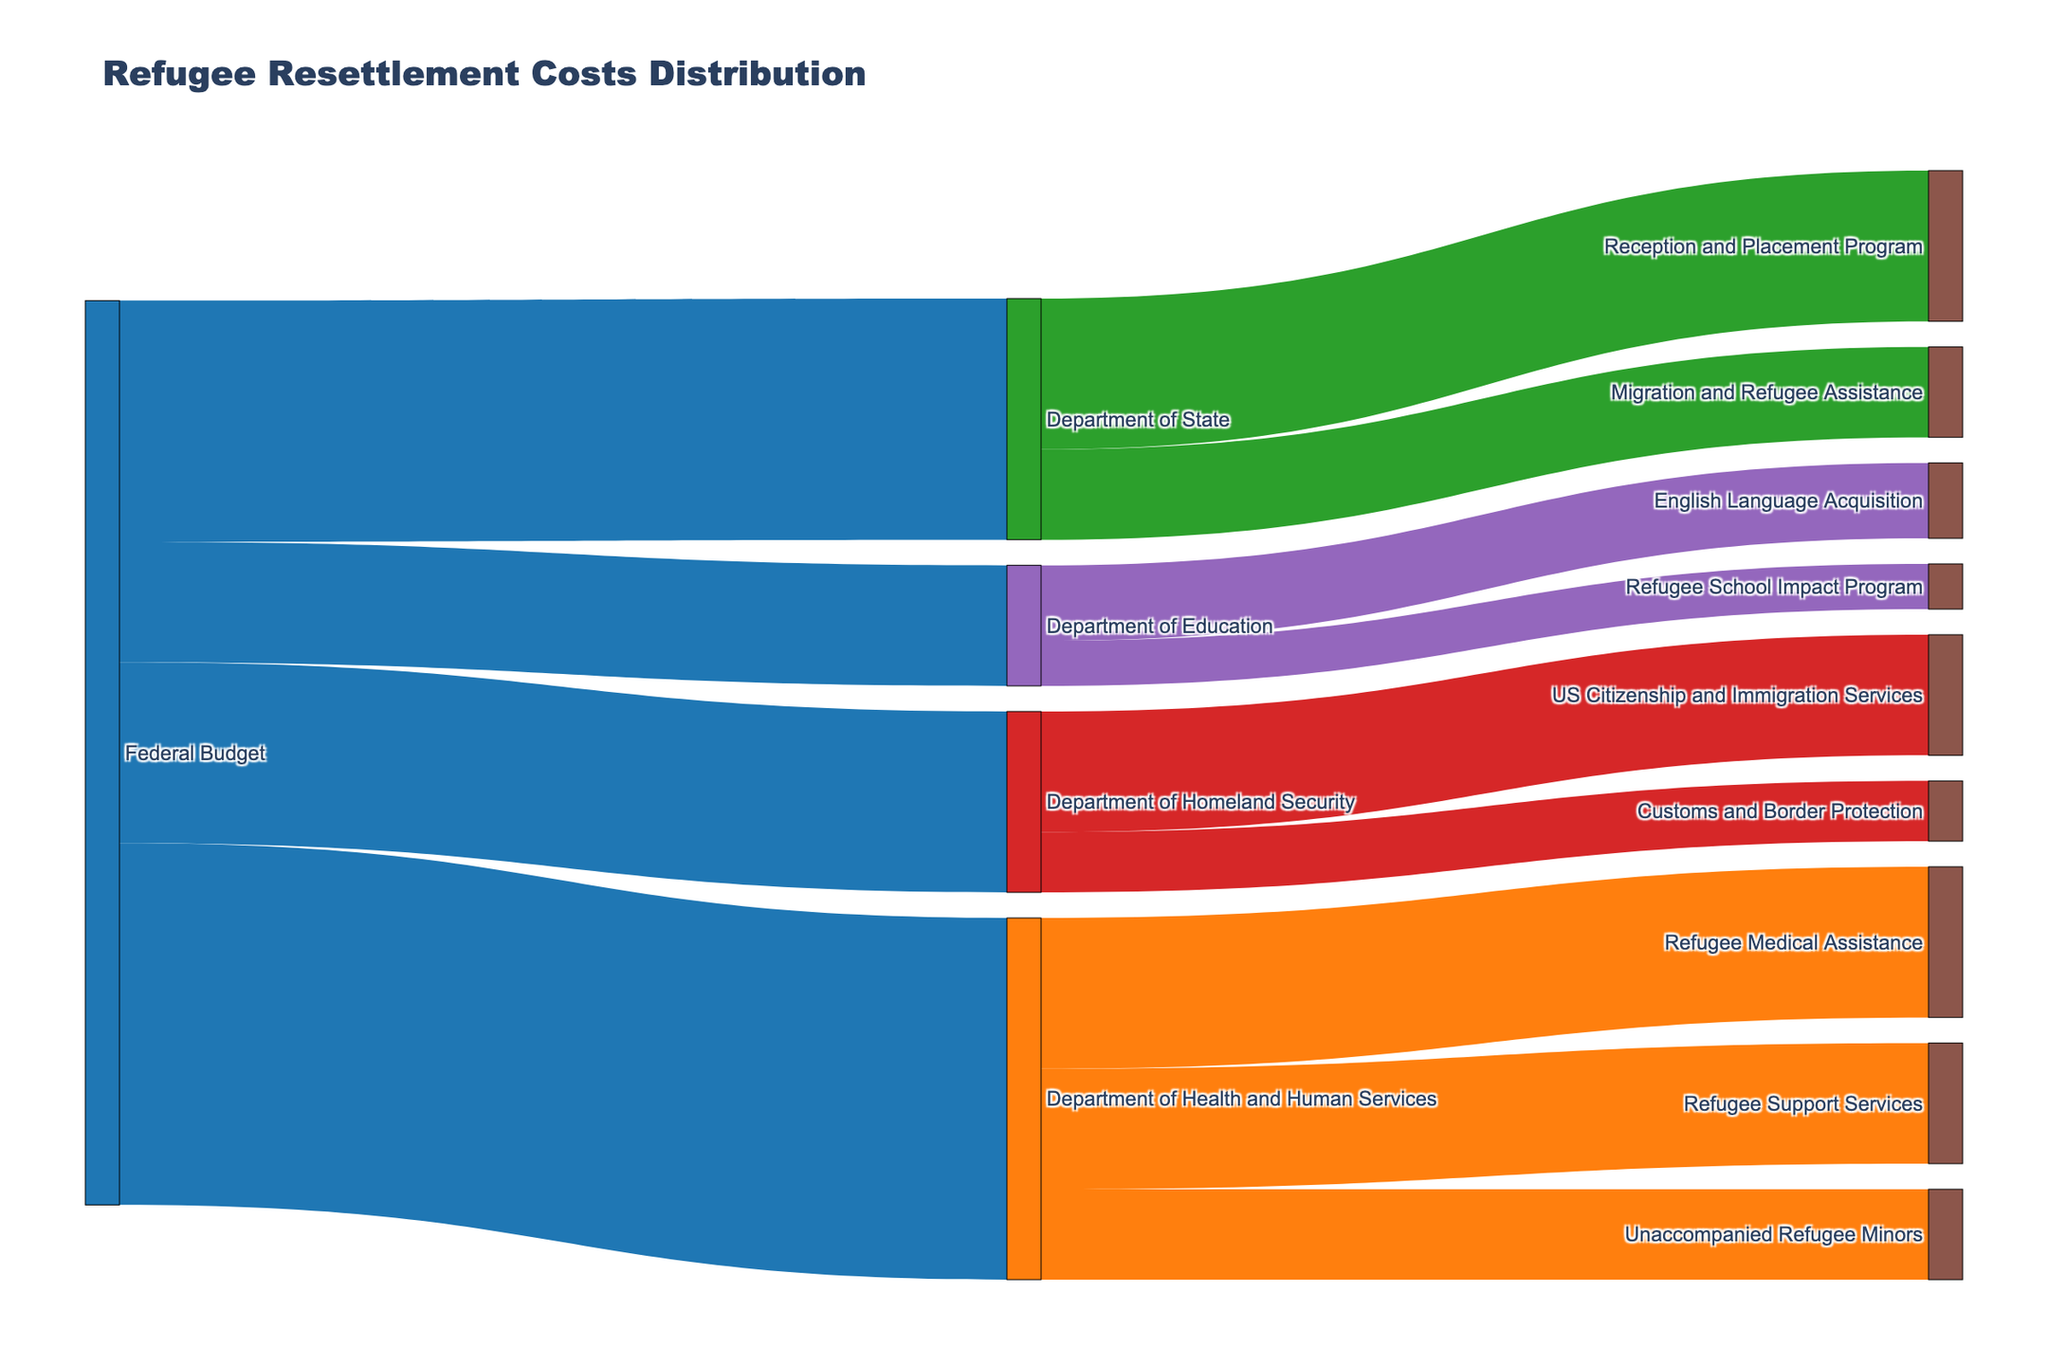Which department gets the largest amount of funding from the Federal Budget? To determine the department that receives the largest amount of funding, look at the values and identify the longest or thickest flow from "Federal Budget". Here, the Department of Health and Human Services receives $1,200,000,000.
Answer: Department of Health and Human Services How much total funding is allocated to the Department of Homeland Security? Sum the values of all the flows to the Department of Homeland Security: $400,000,000 (US Citizenship and Immigration Services) + $200,000,000 (Customs and Border Protection) = $600,000,000.
Answer: $600,000,000 What is the combined funding allocated to the Refugee Medical Assistance and Refugee Support Services programs? Add the values for Refugee Medical Assistance ($500,000,000) and Refugee Support Services ($400,000,000): $500,000,000 + $400,000,000 = $900,000,000.
Answer: $900,000,000 Which two programs under the Department of Education receive funding, and what is the total combined amount? Identify the programs and their values: English Language Acquisition ($250,000,000) and Refugee School Impact Program ($150,000,000). Then, sum the amounts: $250,000,000 + $150,000,000 = $400,000,000.
Answer: English Language Acquisition and Refugee School Impact Program, $400,000,000 Does the Department of State receive more, less, or equal funding compared to the Department of Homeland Security? Compare the total allocations: Department of State receives $800,000,000 while Department of Homeland Security receives $600,000,000. Therefore, the Department of State receives more.
Answer: More What is the total funding allocated by the Federal Budget for refugee resettlement? Sum all the values originating from the Federal Budget: $1,200,000,000 (HHS) + $800,000,000 (State) + $600,000,000 (DHS) + $400,000,000 (Education) = $3,000,000,000.
Answer: $3,000,000,000 Which specific program under the Department of Homeland Security has higher funding, and how much more is it? Compare US Citizenship and Immigration Services ($400,000,000) and Customs and Border Protection ($200,000,000). US Citizenship and Immigration Services has $200,000,000 more.
Answer: US Citizenship and Immigration Services, $200,000,000 more How is the funding of the Department of State distributed between its programs? Identify the values and programs under the Department of State: Reception and Placement Program ($500,000,000) and Migration and Refugee Assistance ($300,000,000). The distribution is $500,000,000 and $300,000,000 respectively.
Answer: $500,000,000 to Reception and Placement Program, $300,000,000 to Migration and Refugee Assistance Which program along the entire distribution receives the least funding? Identify the program with the smallest value in the diagram: Refugee School Impact Program under the Department of Education receives $150,000,000, the smallest in the dataset.
Answer: Refugee School Impact Program 